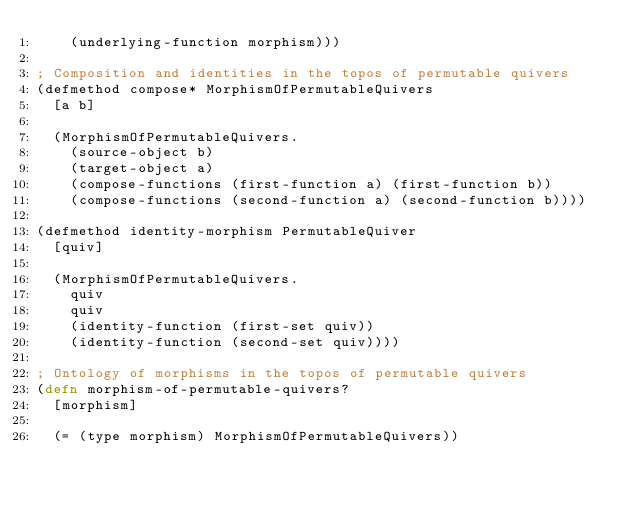Convert code to text. <code><loc_0><loc_0><loc_500><loc_500><_Clojure_>    (underlying-function morphism)))

; Composition and identities in the topos of permutable quivers
(defmethod compose* MorphismOfPermutableQuivers
  [a b]

  (MorphismOfPermutableQuivers.
    (source-object b)
    (target-object a)
    (compose-functions (first-function a) (first-function b))
    (compose-functions (second-function a) (second-function b))))

(defmethod identity-morphism PermutableQuiver
  [quiv]

  (MorphismOfPermutableQuivers.
    quiv
    quiv
    (identity-function (first-set quiv))
    (identity-function (second-set quiv))))

; Ontology of morphisms in the topos of permutable quivers
(defn morphism-of-permutable-quivers?
  [morphism]

  (= (type morphism) MorphismOfPermutableQuivers))


</code> 